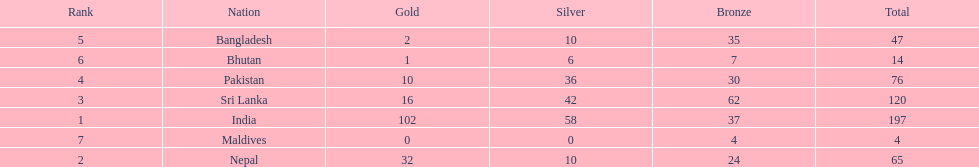What was the only nation to win less than 10 medals total? Maldives. 